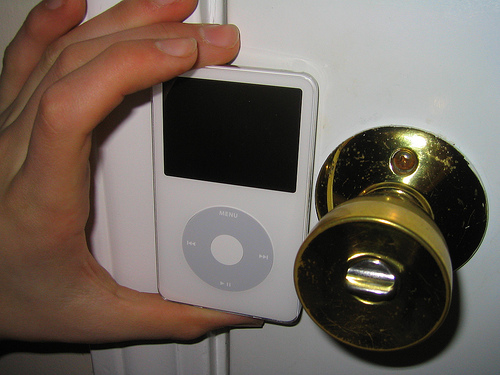<image>
Is the ipod to the right of the doorhandle? No. The ipod is not to the right of the doorhandle. The horizontal positioning shows a different relationship. Is there a door knob on the ipod knob? No. The door knob is not positioned on the ipod knob. They may be near each other, but the door knob is not supported by or resting on top of the ipod knob. Is the ipod to the left of the door knob? Yes. From this viewpoint, the ipod is positioned to the left side relative to the door knob. Is there a ipod to the left of the door? No. The ipod is not to the left of the door. From this viewpoint, they have a different horizontal relationship. Is there a ipod in front of the door knob? No. The ipod is not in front of the door knob. The spatial positioning shows a different relationship between these objects. 